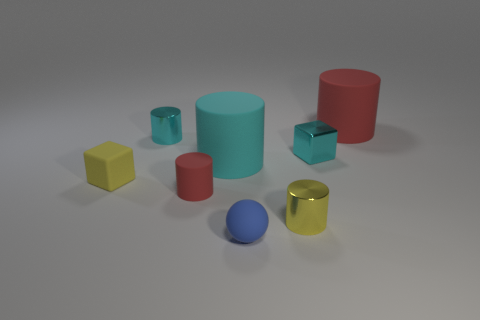There is a red object to the left of the red matte cylinder that is behind the red object in front of the large red thing; what is its shape?
Offer a very short reply. Cylinder. How many other objects are the same shape as the big cyan rubber object?
Keep it short and to the point. 4. There is a matte cylinder that is the same size as the matte ball; what color is it?
Offer a very short reply. Red. How many cylinders are either cyan shiny objects or tiny things?
Your answer should be very brief. 3. How many tiny yellow cylinders are there?
Provide a short and direct response. 1. Do the small red thing and the matte object that is in front of the yellow metal object have the same shape?
Offer a terse response. No. There is a matte cylinder that is the same color as the tiny shiny cube; what size is it?
Provide a short and direct response. Large. What number of things are large red matte objects or large red rubber blocks?
Your answer should be very brief. 1. What is the shape of the big rubber thing that is right of the cube right of the yellow matte block?
Your response must be concise. Cylinder. There is a small cyan object on the left side of the cyan matte cylinder; is it the same shape as the tiny yellow rubber thing?
Your answer should be compact. No. 